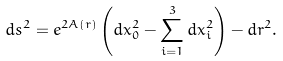Convert formula to latex. <formula><loc_0><loc_0><loc_500><loc_500>d s ^ { 2 } = e ^ { 2 A ( r ) } \left ( d x _ { 0 } ^ { 2 } - \sum _ { i = 1 } ^ { 3 } d x _ { i } ^ { 2 } \right ) - d r ^ { 2 } .</formula> 